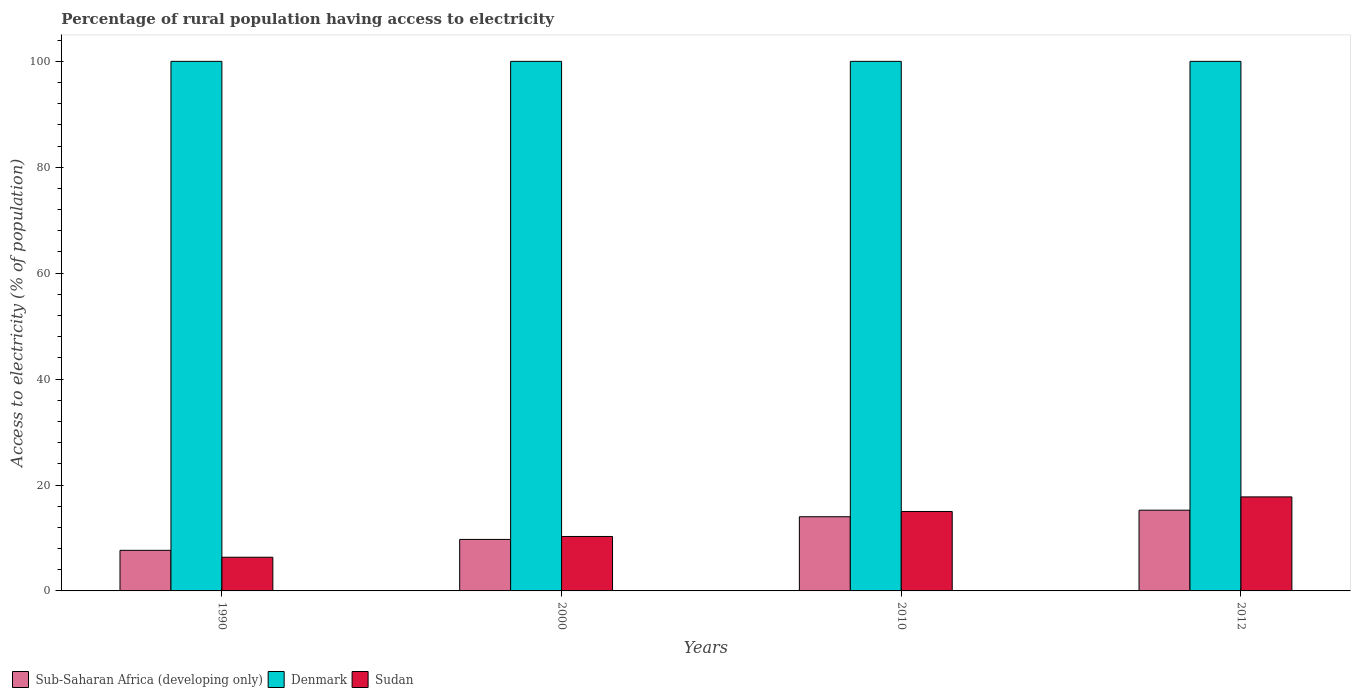How many different coloured bars are there?
Keep it short and to the point. 3. Are the number of bars on each tick of the X-axis equal?
Your answer should be compact. Yes. How many bars are there on the 4th tick from the left?
Keep it short and to the point. 3. What is the percentage of rural population having access to electricity in Sub-Saharan Africa (developing only) in 2000?
Offer a very short reply. 9.73. Across all years, what is the maximum percentage of rural population having access to electricity in Sudan?
Offer a very short reply. 17.75. Across all years, what is the minimum percentage of rural population having access to electricity in Sub-Saharan Africa (developing only)?
Give a very brief answer. 7.66. What is the total percentage of rural population having access to electricity in Sub-Saharan Africa (developing only) in the graph?
Your response must be concise. 46.64. What is the difference between the percentage of rural population having access to electricity in Sudan in 2010 and that in 2012?
Make the answer very short. -2.75. What is the difference between the percentage of rural population having access to electricity in Sub-Saharan Africa (developing only) in 2010 and the percentage of rural population having access to electricity in Sudan in 1990?
Your answer should be compact. 7.65. What is the average percentage of rural population having access to electricity in Sudan per year?
Ensure brevity in your answer.  12.35. In the year 2000, what is the difference between the percentage of rural population having access to electricity in Denmark and percentage of rural population having access to electricity in Sudan?
Give a very brief answer. 89.72. In how many years, is the percentage of rural population having access to electricity in Sub-Saharan Africa (developing only) greater than 88 %?
Your answer should be very brief. 0. What is the ratio of the percentage of rural population having access to electricity in Denmark in 2000 to that in 2012?
Provide a succinct answer. 1. Is the percentage of rural population having access to electricity in Denmark in 1990 less than that in 2012?
Give a very brief answer. No. Is the difference between the percentage of rural population having access to electricity in Denmark in 2010 and 2012 greater than the difference between the percentage of rural population having access to electricity in Sudan in 2010 and 2012?
Offer a terse response. Yes. What is the difference between the highest and the second highest percentage of rural population having access to electricity in Denmark?
Offer a very short reply. 0. What is the difference between the highest and the lowest percentage of rural population having access to electricity in Sudan?
Your answer should be compact. 11.39. In how many years, is the percentage of rural population having access to electricity in Denmark greater than the average percentage of rural population having access to electricity in Denmark taken over all years?
Keep it short and to the point. 0. What does the 1st bar from the left in 1990 represents?
Your response must be concise. Sub-Saharan Africa (developing only). What does the 2nd bar from the right in 2010 represents?
Give a very brief answer. Denmark. Is it the case that in every year, the sum of the percentage of rural population having access to electricity in Sub-Saharan Africa (developing only) and percentage of rural population having access to electricity in Sudan is greater than the percentage of rural population having access to electricity in Denmark?
Keep it short and to the point. No. How many bars are there?
Make the answer very short. 12. Are all the bars in the graph horizontal?
Keep it short and to the point. No. What is the difference between two consecutive major ticks on the Y-axis?
Give a very brief answer. 20. Are the values on the major ticks of Y-axis written in scientific E-notation?
Offer a very short reply. No. Does the graph contain grids?
Offer a very short reply. No. How many legend labels are there?
Provide a succinct answer. 3. How are the legend labels stacked?
Your response must be concise. Horizontal. What is the title of the graph?
Your answer should be compact. Percentage of rural population having access to electricity. Does "American Samoa" appear as one of the legend labels in the graph?
Ensure brevity in your answer.  No. What is the label or title of the X-axis?
Provide a short and direct response. Years. What is the label or title of the Y-axis?
Provide a succinct answer. Access to electricity (% of population). What is the Access to electricity (% of population) of Sub-Saharan Africa (developing only) in 1990?
Provide a short and direct response. 7.66. What is the Access to electricity (% of population) in Sudan in 1990?
Make the answer very short. 6.36. What is the Access to electricity (% of population) of Sub-Saharan Africa (developing only) in 2000?
Your answer should be compact. 9.73. What is the Access to electricity (% of population) in Sudan in 2000?
Provide a succinct answer. 10.28. What is the Access to electricity (% of population) of Sub-Saharan Africa (developing only) in 2010?
Make the answer very short. 14.01. What is the Access to electricity (% of population) in Sudan in 2010?
Provide a succinct answer. 15. What is the Access to electricity (% of population) in Sub-Saharan Africa (developing only) in 2012?
Your answer should be very brief. 15.24. What is the Access to electricity (% of population) in Sudan in 2012?
Provide a short and direct response. 17.75. Across all years, what is the maximum Access to electricity (% of population) of Sub-Saharan Africa (developing only)?
Your response must be concise. 15.24. Across all years, what is the maximum Access to electricity (% of population) in Denmark?
Make the answer very short. 100. Across all years, what is the maximum Access to electricity (% of population) in Sudan?
Provide a succinct answer. 17.75. Across all years, what is the minimum Access to electricity (% of population) in Sub-Saharan Africa (developing only)?
Ensure brevity in your answer.  7.66. Across all years, what is the minimum Access to electricity (% of population) of Sudan?
Give a very brief answer. 6.36. What is the total Access to electricity (% of population) of Sub-Saharan Africa (developing only) in the graph?
Your response must be concise. 46.64. What is the total Access to electricity (% of population) of Denmark in the graph?
Keep it short and to the point. 400. What is the total Access to electricity (% of population) of Sudan in the graph?
Offer a terse response. 49.4. What is the difference between the Access to electricity (% of population) in Sub-Saharan Africa (developing only) in 1990 and that in 2000?
Keep it short and to the point. -2.06. What is the difference between the Access to electricity (% of population) of Sudan in 1990 and that in 2000?
Your response must be concise. -3.92. What is the difference between the Access to electricity (% of population) of Sub-Saharan Africa (developing only) in 1990 and that in 2010?
Your response must be concise. -6.34. What is the difference between the Access to electricity (% of population) in Denmark in 1990 and that in 2010?
Offer a very short reply. 0. What is the difference between the Access to electricity (% of population) of Sudan in 1990 and that in 2010?
Give a very brief answer. -8.64. What is the difference between the Access to electricity (% of population) of Sub-Saharan Africa (developing only) in 1990 and that in 2012?
Keep it short and to the point. -7.58. What is the difference between the Access to electricity (% of population) of Sudan in 1990 and that in 2012?
Provide a short and direct response. -11.39. What is the difference between the Access to electricity (% of population) in Sub-Saharan Africa (developing only) in 2000 and that in 2010?
Make the answer very short. -4.28. What is the difference between the Access to electricity (% of population) in Sudan in 2000 and that in 2010?
Your answer should be very brief. -4.72. What is the difference between the Access to electricity (% of population) in Sub-Saharan Africa (developing only) in 2000 and that in 2012?
Your answer should be compact. -5.52. What is the difference between the Access to electricity (% of population) in Denmark in 2000 and that in 2012?
Offer a very short reply. 0. What is the difference between the Access to electricity (% of population) of Sudan in 2000 and that in 2012?
Make the answer very short. -7.47. What is the difference between the Access to electricity (% of population) in Sub-Saharan Africa (developing only) in 2010 and that in 2012?
Your answer should be compact. -1.24. What is the difference between the Access to electricity (% of population) in Denmark in 2010 and that in 2012?
Offer a terse response. 0. What is the difference between the Access to electricity (% of population) in Sudan in 2010 and that in 2012?
Keep it short and to the point. -2.75. What is the difference between the Access to electricity (% of population) in Sub-Saharan Africa (developing only) in 1990 and the Access to electricity (% of population) in Denmark in 2000?
Provide a succinct answer. -92.34. What is the difference between the Access to electricity (% of population) in Sub-Saharan Africa (developing only) in 1990 and the Access to electricity (% of population) in Sudan in 2000?
Your answer should be very brief. -2.62. What is the difference between the Access to electricity (% of population) in Denmark in 1990 and the Access to electricity (% of population) in Sudan in 2000?
Provide a succinct answer. 89.72. What is the difference between the Access to electricity (% of population) of Sub-Saharan Africa (developing only) in 1990 and the Access to electricity (% of population) of Denmark in 2010?
Provide a short and direct response. -92.34. What is the difference between the Access to electricity (% of population) in Sub-Saharan Africa (developing only) in 1990 and the Access to electricity (% of population) in Sudan in 2010?
Provide a succinct answer. -7.34. What is the difference between the Access to electricity (% of population) in Sub-Saharan Africa (developing only) in 1990 and the Access to electricity (% of population) in Denmark in 2012?
Your answer should be compact. -92.34. What is the difference between the Access to electricity (% of population) in Sub-Saharan Africa (developing only) in 1990 and the Access to electricity (% of population) in Sudan in 2012?
Provide a succinct answer. -10.09. What is the difference between the Access to electricity (% of population) in Denmark in 1990 and the Access to electricity (% of population) in Sudan in 2012?
Provide a short and direct response. 82.25. What is the difference between the Access to electricity (% of population) of Sub-Saharan Africa (developing only) in 2000 and the Access to electricity (% of population) of Denmark in 2010?
Offer a very short reply. -90.27. What is the difference between the Access to electricity (% of population) of Sub-Saharan Africa (developing only) in 2000 and the Access to electricity (% of population) of Sudan in 2010?
Offer a very short reply. -5.27. What is the difference between the Access to electricity (% of population) of Sub-Saharan Africa (developing only) in 2000 and the Access to electricity (% of population) of Denmark in 2012?
Ensure brevity in your answer.  -90.27. What is the difference between the Access to electricity (% of population) of Sub-Saharan Africa (developing only) in 2000 and the Access to electricity (% of population) of Sudan in 2012?
Provide a succinct answer. -8.03. What is the difference between the Access to electricity (% of population) in Denmark in 2000 and the Access to electricity (% of population) in Sudan in 2012?
Provide a succinct answer. 82.25. What is the difference between the Access to electricity (% of population) of Sub-Saharan Africa (developing only) in 2010 and the Access to electricity (% of population) of Denmark in 2012?
Your answer should be very brief. -85.99. What is the difference between the Access to electricity (% of population) of Sub-Saharan Africa (developing only) in 2010 and the Access to electricity (% of population) of Sudan in 2012?
Offer a very short reply. -3.75. What is the difference between the Access to electricity (% of population) in Denmark in 2010 and the Access to electricity (% of population) in Sudan in 2012?
Provide a succinct answer. 82.25. What is the average Access to electricity (% of population) in Sub-Saharan Africa (developing only) per year?
Make the answer very short. 11.66. What is the average Access to electricity (% of population) of Denmark per year?
Provide a succinct answer. 100. What is the average Access to electricity (% of population) in Sudan per year?
Provide a short and direct response. 12.35. In the year 1990, what is the difference between the Access to electricity (% of population) in Sub-Saharan Africa (developing only) and Access to electricity (% of population) in Denmark?
Provide a succinct answer. -92.34. In the year 1990, what is the difference between the Access to electricity (% of population) of Sub-Saharan Africa (developing only) and Access to electricity (% of population) of Sudan?
Offer a very short reply. 1.3. In the year 1990, what is the difference between the Access to electricity (% of population) in Denmark and Access to electricity (% of population) in Sudan?
Your answer should be very brief. 93.64. In the year 2000, what is the difference between the Access to electricity (% of population) of Sub-Saharan Africa (developing only) and Access to electricity (% of population) of Denmark?
Keep it short and to the point. -90.27. In the year 2000, what is the difference between the Access to electricity (% of population) of Sub-Saharan Africa (developing only) and Access to electricity (% of population) of Sudan?
Ensure brevity in your answer.  -0.55. In the year 2000, what is the difference between the Access to electricity (% of population) of Denmark and Access to electricity (% of population) of Sudan?
Provide a succinct answer. 89.72. In the year 2010, what is the difference between the Access to electricity (% of population) in Sub-Saharan Africa (developing only) and Access to electricity (% of population) in Denmark?
Your answer should be very brief. -85.99. In the year 2010, what is the difference between the Access to electricity (% of population) in Sub-Saharan Africa (developing only) and Access to electricity (% of population) in Sudan?
Make the answer very short. -0.99. In the year 2010, what is the difference between the Access to electricity (% of population) of Denmark and Access to electricity (% of population) of Sudan?
Provide a short and direct response. 85. In the year 2012, what is the difference between the Access to electricity (% of population) in Sub-Saharan Africa (developing only) and Access to electricity (% of population) in Denmark?
Your answer should be very brief. -84.76. In the year 2012, what is the difference between the Access to electricity (% of population) of Sub-Saharan Africa (developing only) and Access to electricity (% of population) of Sudan?
Ensure brevity in your answer.  -2.51. In the year 2012, what is the difference between the Access to electricity (% of population) in Denmark and Access to electricity (% of population) in Sudan?
Make the answer very short. 82.25. What is the ratio of the Access to electricity (% of population) of Sub-Saharan Africa (developing only) in 1990 to that in 2000?
Keep it short and to the point. 0.79. What is the ratio of the Access to electricity (% of population) in Sudan in 1990 to that in 2000?
Offer a very short reply. 0.62. What is the ratio of the Access to electricity (% of population) in Sub-Saharan Africa (developing only) in 1990 to that in 2010?
Make the answer very short. 0.55. What is the ratio of the Access to electricity (% of population) of Sudan in 1990 to that in 2010?
Provide a succinct answer. 0.42. What is the ratio of the Access to electricity (% of population) of Sub-Saharan Africa (developing only) in 1990 to that in 2012?
Give a very brief answer. 0.5. What is the ratio of the Access to electricity (% of population) in Denmark in 1990 to that in 2012?
Your answer should be very brief. 1. What is the ratio of the Access to electricity (% of population) in Sudan in 1990 to that in 2012?
Offer a very short reply. 0.36. What is the ratio of the Access to electricity (% of population) in Sub-Saharan Africa (developing only) in 2000 to that in 2010?
Ensure brevity in your answer.  0.69. What is the ratio of the Access to electricity (% of population) in Sudan in 2000 to that in 2010?
Your response must be concise. 0.69. What is the ratio of the Access to electricity (% of population) of Sub-Saharan Africa (developing only) in 2000 to that in 2012?
Provide a succinct answer. 0.64. What is the ratio of the Access to electricity (% of population) in Denmark in 2000 to that in 2012?
Offer a terse response. 1. What is the ratio of the Access to electricity (% of population) of Sudan in 2000 to that in 2012?
Offer a terse response. 0.58. What is the ratio of the Access to electricity (% of population) of Sub-Saharan Africa (developing only) in 2010 to that in 2012?
Offer a terse response. 0.92. What is the ratio of the Access to electricity (% of population) of Denmark in 2010 to that in 2012?
Give a very brief answer. 1. What is the ratio of the Access to electricity (% of population) in Sudan in 2010 to that in 2012?
Make the answer very short. 0.84. What is the difference between the highest and the second highest Access to electricity (% of population) of Sub-Saharan Africa (developing only)?
Provide a succinct answer. 1.24. What is the difference between the highest and the second highest Access to electricity (% of population) of Sudan?
Keep it short and to the point. 2.75. What is the difference between the highest and the lowest Access to electricity (% of population) of Sub-Saharan Africa (developing only)?
Your answer should be compact. 7.58. What is the difference between the highest and the lowest Access to electricity (% of population) in Denmark?
Keep it short and to the point. 0. What is the difference between the highest and the lowest Access to electricity (% of population) in Sudan?
Offer a very short reply. 11.39. 